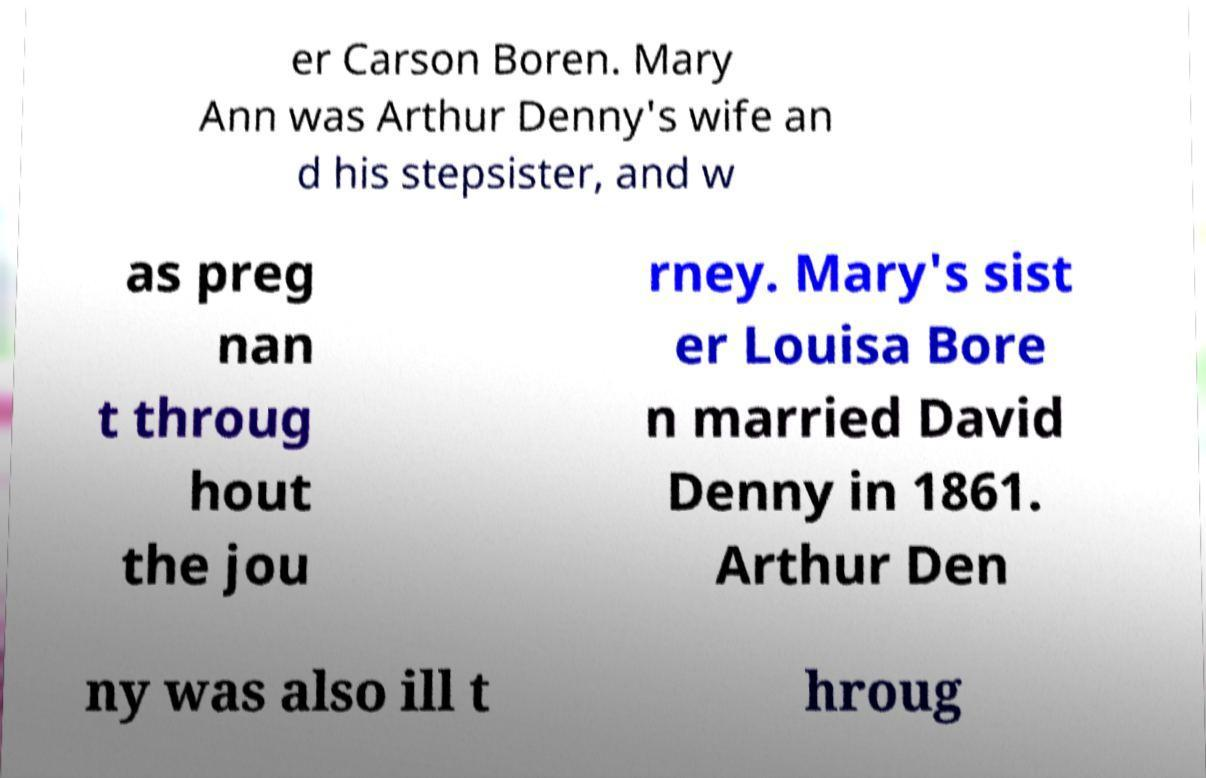I need the written content from this picture converted into text. Can you do that? er Carson Boren. Mary Ann was Arthur Denny's wife an d his stepsister, and w as preg nan t throug hout the jou rney. Mary's sist er Louisa Bore n married David Denny in 1861. Arthur Den ny was also ill t hroug 